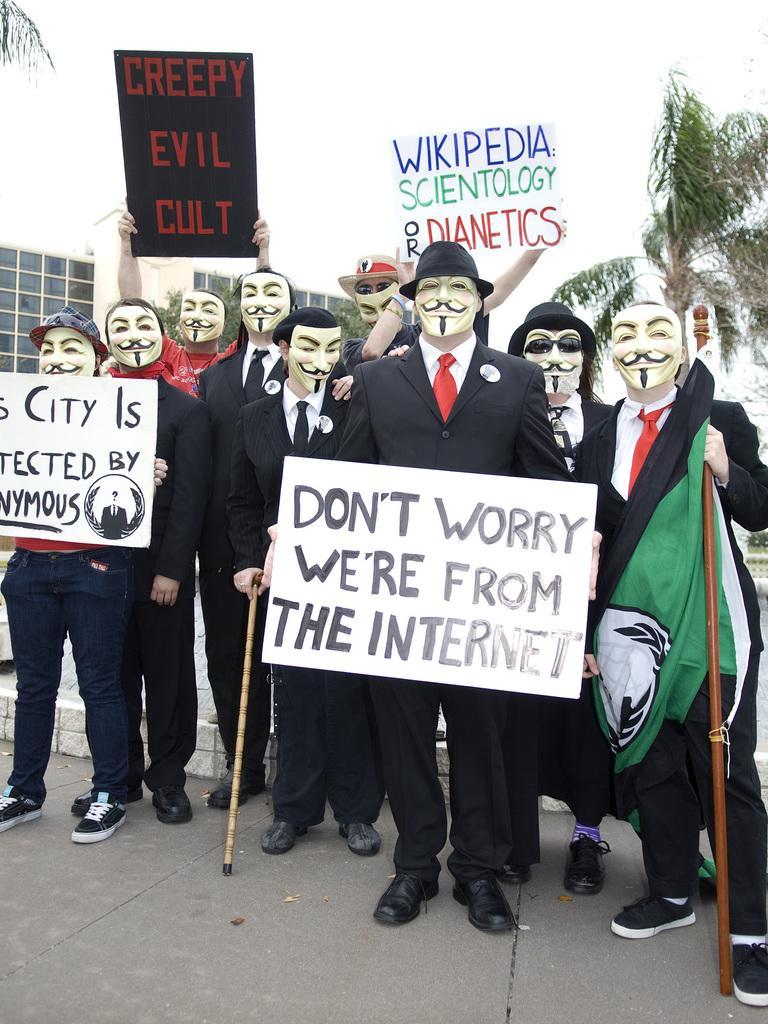Please provide a concise description of this image. In this picture we can see a group of people in the fancy dress and some people holding the boards and sticks. Behind the people there are trees, building and a sky. 